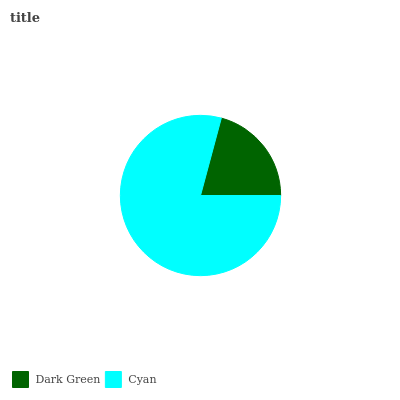Is Dark Green the minimum?
Answer yes or no. Yes. Is Cyan the maximum?
Answer yes or no. Yes. Is Cyan the minimum?
Answer yes or no. No. Is Cyan greater than Dark Green?
Answer yes or no. Yes. Is Dark Green less than Cyan?
Answer yes or no. Yes. Is Dark Green greater than Cyan?
Answer yes or no. No. Is Cyan less than Dark Green?
Answer yes or no. No. Is Cyan the high median?
Answer yes or no. Yes. Is Dark Green the low median?
Answer yes or no. Yes. Is Dark Green the high median?
Answer yes or no. No. Is Cyan the low median?
Answer yes or no. No. 